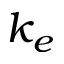Convert formula to latex. <formula><loc_0><loc_0><loc_500><loc_500>k _ { e }</formula> 